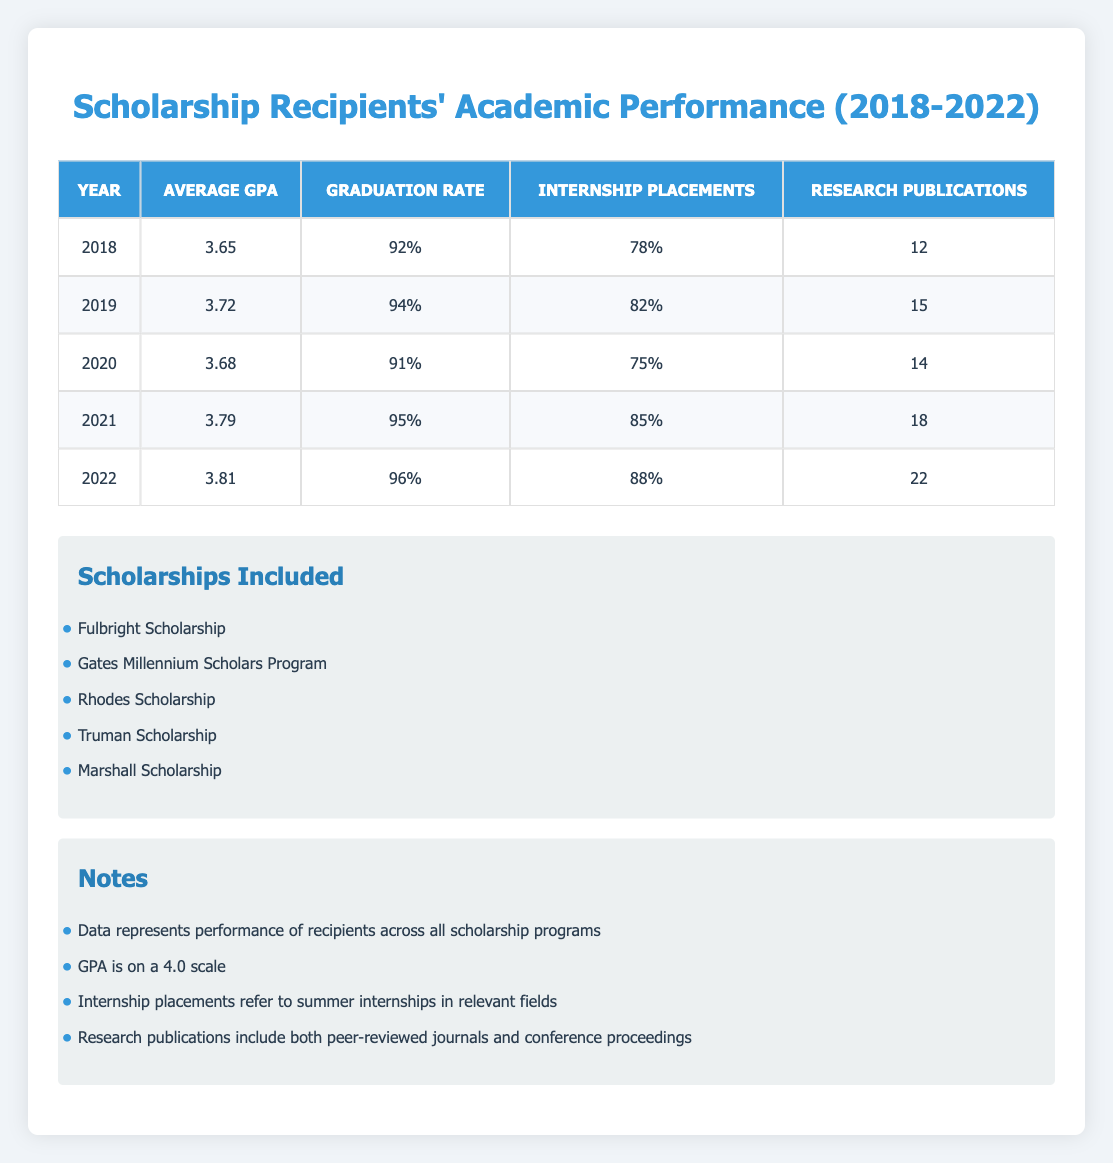What was the average GPA of scholarship recipients in 2021? The table shows the average GPA for each year. In 2021, it is clearly stated as 3.79 under the "Average GPA" column for that year.
Answer: 3.79 In which year was the graduation rate at its highest? Review the "Graduation Rate" column for each year. The highest rate is 96%, which appears in the year 2022.
Answer: 2022 What was the percentage increase in internship placements from 2018 to 2022? The internship placements in 2018 were 78%, and in 2022, they were 88%. The increase is calculated as (88% - 78%)/78% * 100 = 12.82%.
Answer: 12.82% Was there a year when the average GPA dropped compared to the previous year? By examining the "Average GPA" column year by year, we can see that the GPA fell from 3.72 in 2019 to 3.68 in 2020. Hence, there was a drop in that period.
Answer: Yes What is the total number of research publications across all years? Adding the number of research publications for each year: 12 + 15 + 14 + 18 + 22 = 81. Thus, the total for all years combined is 81.
Answer: 81 What was the average graduation rate over the five years? To find the average, first sum the graduation rates (92% + 94% + 91% + 95% + 96% = 468%), and then divide by 5 (468% / 5 = 93.6%). Thus, the average graduation rate is 93.6%.
Answer: 93.6% Did the average GPA consistently increase from 2018 to 2022? Reviewing the "Average GPA" column, we can see the values for each year: 3.65, 3.72, 3.68, 3.79, 3.81. The GPA did not consistently increase due to the drop from 2019 to 2020.
Answer: No How many more research publications were reported in 2022 compared to 2018? The number of research publications in 2022 is 22, while in 2018, it was 12. To find the difference, we calculate 22 - 12 = 10. Therefore, there were 10 more publications in 2022 than in 2018.
Answer: 10 